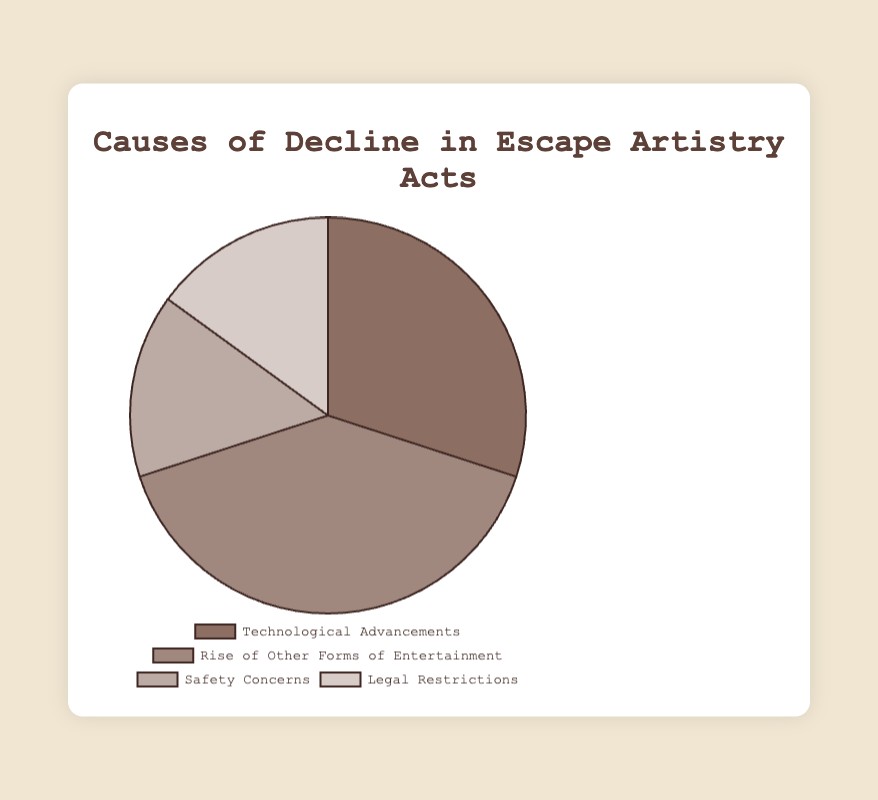Which cause has the highest percentage? According to the pie chart, the cause with the highest percentage is 'Rise of Other Forms of Entertainment' at 40%. This can be visually identified as the largest section of the pie chart.
Answer: Rise of Other Forms of Entertainment What is the combined percentage of Safety Concerns and Legal Restrictions? From the pie chart, Safety Concerns and Legal Restrictions each have a percentage of 15%. Adding these together, 15% + 15% = 30%.
Answer: 30% Which two causes have equal percentages? The pie chart shows that Safety Concerns and Legal Restrictions both have the same percentage of 15%. This is seen as the two equivalent sections of the chart.
Answer: Safety Concerns and Legal Restrictions How much greater is the percentage of 'Rise of Other Forms of Entertainment' compared to 'Technological Advancements'? The percentage of 'Rise of Other Forms of Entertainment' is 40%, and 'Technological Advancements' is 30%. The difference between them is 40% - 30% = 10%.
Answer: 10% Which section of the pie chart is represented by the lightest color? The segment corresponding to 'Legal Restrictions' is the lightest color. This can be identified visually as the light beige/tan part of the pie chart.
Answer: Legal Restrictions What fraction of the pie chart does 'Technological Advancements' and 'Safety Concerns' together represent? 'Technological Advancements' is 30% and 'Safety Concerns' is 15%. Combined, they make up 30% + 15% = 45%, which is 45/100 or simplified to 9/20 of the pie chart.
Answer: 9/20 Arrange the causes in ascending order of their percentages. The percentages of the causes are: Safety Concerns (15%), Legal Restrictions (15%), Technological Advancements (30%), and Rise of Other Forms of Entertainment (40%). Ascending order is: Safety Concerns, Legal Restrictions, Technological Advancements, Rise of Other Forms of Entertainment.
Answer: Safety Concerns, Legal Restrictions, Technological Advancements, Rise of Other Forms of Entertainment 